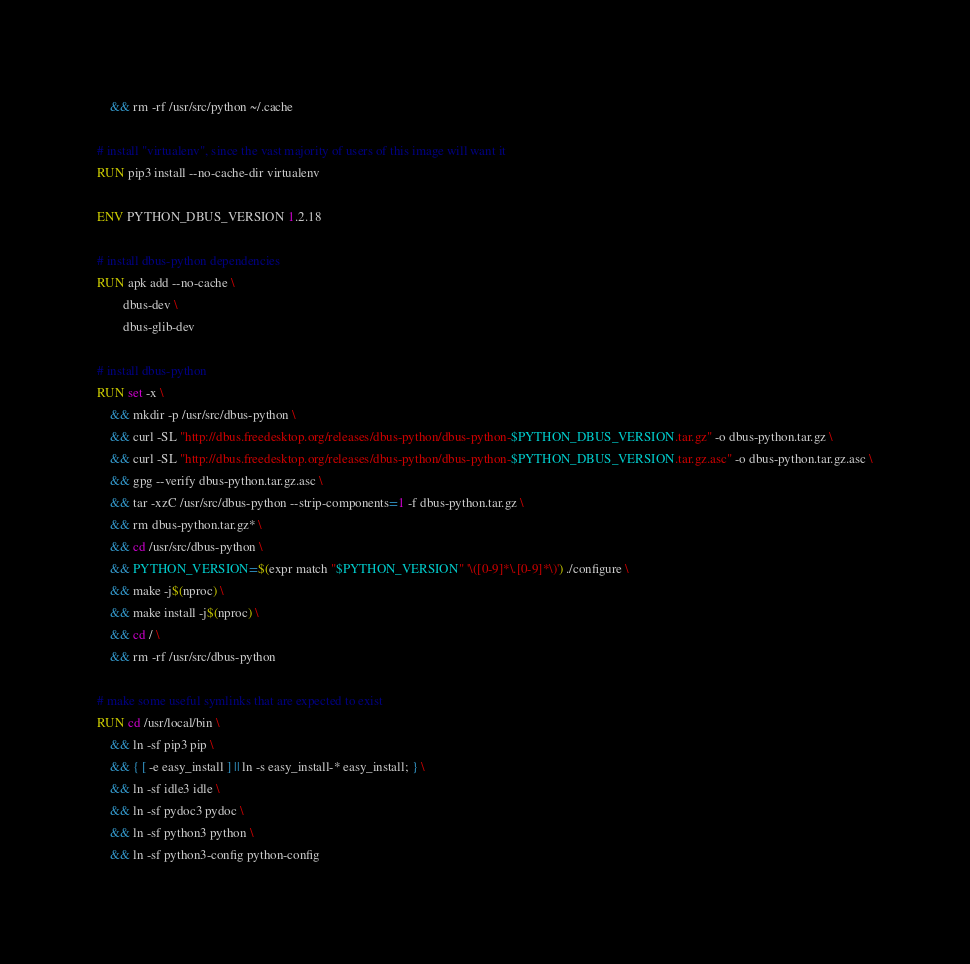Convert code to text. <code><loc_0><loc_0><loc_500><loc_500><_Dockerfile_>	&& rm -rf /usr/src/python ~/.cache

# install "virtualenv", since the vast majority of users of this image will want it
RUN pip3 install --no-cache-dir virtualenv

ENV PYTHON_DBUS_VERSION 1.2.18

# install dbus-python dependencies 
RUN apk add --no-cache \
		dbus-dev \
		dbus-glib-dev

# install dbus-python
RUN set -x \
	&& mkdir -p /usr/src/dbus-python \
	&& curl -SL "http://dbus.freedesktop.org/releases/dbus-python/dbus-python-$PYTHON_DBUS_VERSION.tar.gz" -o dbus-python.tar.gz \
	&& curl -SL "http://dbus.freedesktop.org/releases/dbus-python/dbus-python-$PYTHON_DBUS_VERSION.tar.gz.asc" -o dbus-python.tar.gz.asc \
	&& gpg --verify dbus-python.tar.gz.asc \
	&& tar -xzC /usr/src/dbus-python --strip-components=1 -f dbus-python.tar.gz \
	&& rm dbus-python.tar.gz* \
	&& cd /usr/src/dbus-python \
	&& PYTHON_VERSION=$(expr match "$PYTHON_VERSION" '\([0-9]*\.[0-9]*\)') ./configure \
	&& make -j$(nproc) \
	&& make install -j$(nproc) \
	&& cd / \
	&& rm -rf /usr/src/dbus-python

# make some useful symlinks that are expected to exist
RUN cd /usr/local/bin \
	&& ln -sf pip3 pip \
	&& { [ -e easy_install ] || ln -s easy_install-* easy_install; } \
	&& ln -sf idle3 idle \
	&& ln -sf pydoc3 pydoc \
	&& ln -sf python3 python \
	&& ln -sf python3-config python-config
</code> 